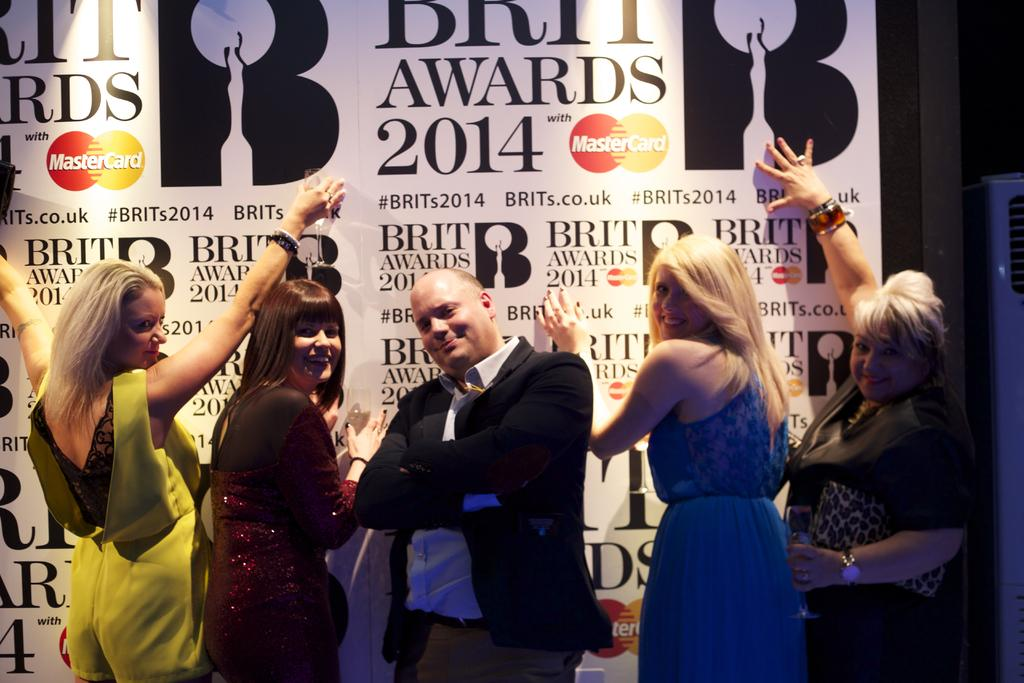What is the main subject of the image? The main subject of the image is the persons standing in the center. Can you describe the background of the image? There is a wall in the background of the image. What type of invention is being showcased by the company in the image? There is no mention of a company or an invention in the image. 